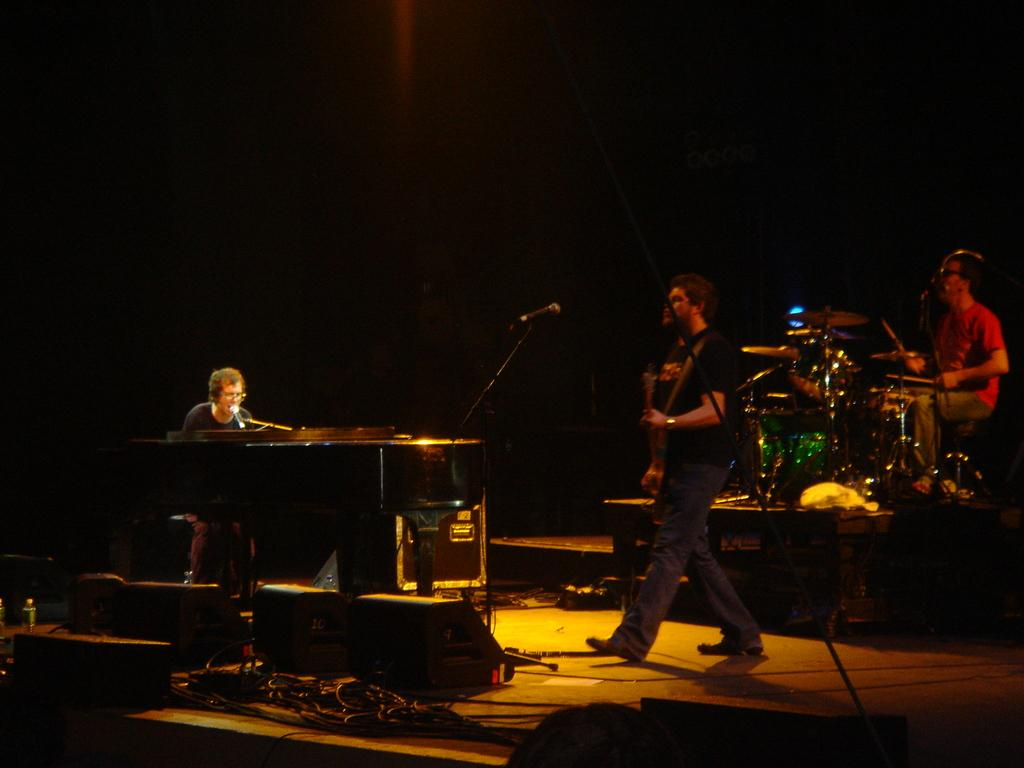What is the person in front of in the image? The person is sitting in front of a piano. Are there any other people in the image besides the person at the piano? Yes, there are people standing in the image. What is the other person sitting near in the image? The other person is sitting near a drum set. What type of glove is the person wearing while playing the piano in the image? There is no glove mentioned or visible in the image. How does the earth factor into the image? The image does not depict any aspect of the earth; it is focused on people and musical instruments. 